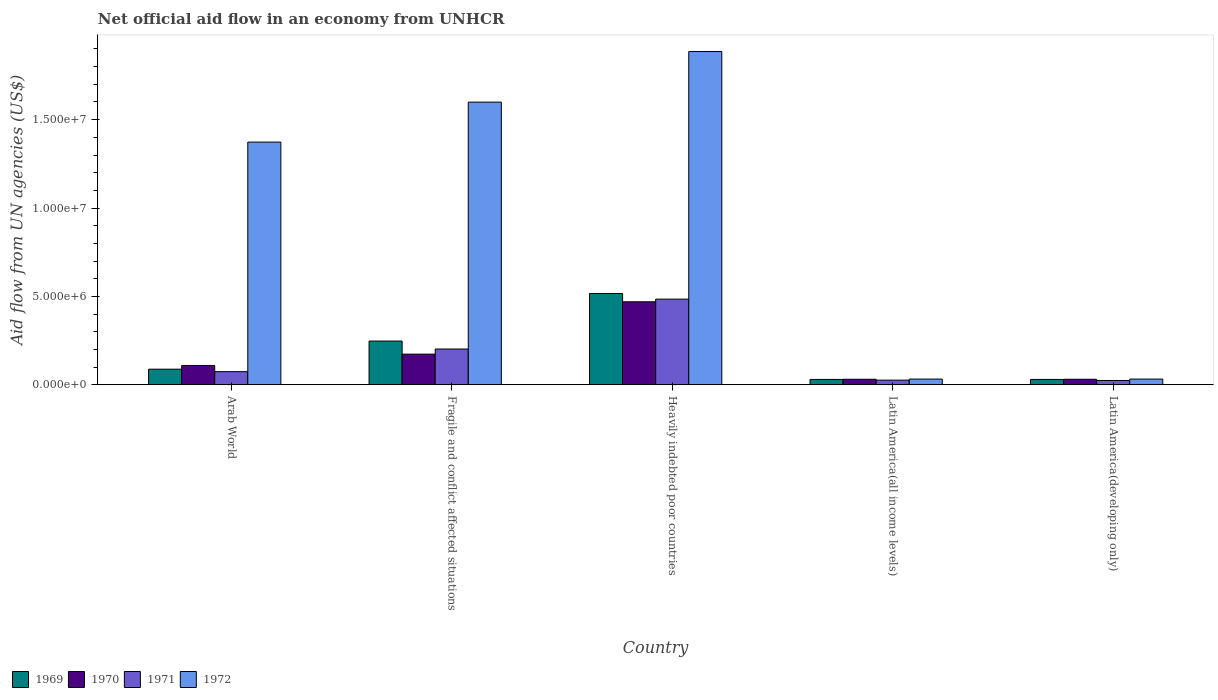How many different coloured bars are there?
Provide a short and direct response. 4. Are the number of bars per tick equal to the number of legend labels?
Provide a short and direct response. Yes. How many bars are there on the 3rd tick from the left?
Provide a short and direct response. 4. How many bars are there on the 2nd tick from the right?
Provide a short and direct response. 4. What is the label of the 2nd group of bars from the left?
Give a very brief answer. Fragile and conflict affected situations. What is the net official aid flow in 1970 in Heavily indebted poor countries?
Provide a succinct answer. 4.70e+06. Across all countries, what is the maximum net official aid flow in 1972?
Offer a terse response. 1.88e+07. In which country was the net official aid flow in 1970 maximum?
Offer a very short reply. Heavily indebted poor countries. In which country was the net official aid flow in 1970 minimum?
Your answer should be compact. Latin America(all income levels). What is the total net official aid flow in 1969 in the graph?
Your answer should be compact. 9.16e+06. What is the difference between the net official aid flow in 1969 in Arab World and that in Fragile and conflict affected situations?
Your answer should be compact. -1.59e+06. What is the difference between the net official aid flow in 1970 in Latin America(all income levels) and the net official aid flow in 1971 in Fragile and conflict affected situations?
Your answer should be very brief. -1.71e+06. What is the average net official aid flow in 1972 per country?
Keep it short and to the point. 9.85e+06. What is the ratio of the net official aid flow in 1971 in Arab World to that in Fragile and conflict affected situations?
Ensure brevity in your answer.  0.37. What is the difference between the highest and the second highest net official aid flow in 1972?
Your answer should be compact. 2.86e+06. What is the difference between the highest and the lowest net official aid flow in 1972?
Ensure brevity in your answer.  1.85e+07. In how many countries, is the net official aid flow in 1969 greater than the average net official aid flow in 1969 taken over all countries?
Your answer should be very brief. 2. Is it the case that in every country, the sum of the net official aid flow in 1971 and net official aid flow in 1969 is greater than the sum of net official aid flow in 1970 and net official aid flow in 1972?
Offer a very short reply. No. What does the 4th bar from the left in Arab World represents?
Your response must be concise. 1972. What does the 2nd bar from the right in Fragile and conflict affected situations represents?
Your response must be concise. 1971. Is it the case that in every country, the sum of the net official aid flow in 1971 and net official aid flow in 1970 is greater than the net official aid flow in 1972?
Offer a very short reply. No. Are all the bars in the graph horizontal?
Provide a succinct answer. No. Are the values on the major ticks of Y-axis written in scientific E-notation?
Provide a short and direct response. Yes. Where does the legend appear in the graph?
Your response must be concise. Bottom left. How many legend labels are there?
Your response must be concise. 4. How are the legend labels stacked?
Your answer should be very brief. Horizontal. What is the title of the graph?
Ensure brevity in your answer.  Net official aid flow in an economy from UNHCR. What is the label or title of the Y-axis?
Provide a short and direct response. Aid flow from UN agencies (US$). What is the Aid flow from UN agencies (US$) in 1969 in Arab World?
Offer a very short reply. 8.90e+05. What is the Aid flow from UN agencies (US$) in 1970 in Arab World?
Make the answer very short. 1.10e+06. What is the Aid flow from UN agencies (US$) in 1971 in Arab World?
Offer a terse response. 7.50e+05. What is the Aid flow from UN agencies (US$) of 1972 in Arab World?
Provide a succinct answer. 1.37e+07. What is the Aid flow from UN agencies (US$) in 1969 in Fragile and conflict affected situations?
Make the answer very short. 2.48e+06. What is the Aid flow from UN agencies (US$) in 1970 in Fragile and conflict affected situations?
Offer a terse response. 1.74e+06. What is the Aid flow from UN agencies (US$) of 1971 in Fragile and conflict affected situations?
Offer a terse response. 2.03e+06. What is the Aid flow from UN agencies (US$) in 1972 in Fragile and conflict affected situations?
Offer a very short reply. 1.60e+07. What is the Aid flow from UN agencies (US$) in 1969 in Heavily indebted poor countries?
Provide a succinct answer. 5.17e+06. What is the Aid flow from UN agencies (US$) in 1970 in Heavily indebted poor countries?
Your answer should be very brief. 4.70e+06. What is the Aid flow from UN agencies (US$) of 1971 in Heavily indebted poor countries?
Provide a succinct answer. 4.85e+06. What is the Aid flow from UN agencies (US$) in 1972 in Heavily indebted poor countries?
Your answer should be very brief. 1.88e+07. What is the Aid flow from UN agencies (US$) of 1970 in Latin America(all income levels)?
Your answer should be compact. 3.20e+05. What is the Aid flow from UN agencies (US$) of 1969 in Latin America(developing only)?
Provide a short and direct response. 3.10e+05. What is the Aid flow from UN agencies (US$) of 1971 in Latin America(developing only)?
Your answer should be very brief. 2.50e+05. What is the Aid flow from UN agencies (US$) in 1972 in Latin America(developing only)?
Offer a terse response. 3.30e+05. Across all countries, what is the maximum Aid flow from UN agencies (US$) in 1969?
Your answer should be very brief. 5.17e+06. Across all countries, what is the maximum Aid flow from UN agencies (US$) in 1970?
Provide a short and direct response. 4.70e+06. Across all countries, what is the maximum Aid flow from UN agencies (US$) in 1971?
Ensure brevity in your answer.  4.85e+06. Across all countries, what is the maximum Aid flow from UN agencies (US$) in 1972?
Keep it short and to the point. 1.88e+07. Across all countries, what is the minimum Aid flow from UN agencies (US$) of 1969?
Offer a very short reply. 3.10e+05. Across all countries, what is the minimum Aid flow from UN agencies (US$) in 1972?
Your answer should be very brief. 3.30e+05. What is the total Aid flow from UN agencies (US$) in 1969 in the graph?
Give a very brief answer. 9.16e+06. What is the total Aid flow from UN agencies (US$) of 1970 in the graph?
Offer a very short reply. 8.18e+06. What is the total Aid flow from UN agencies (US$) of 1971 in the graph?
Keep it short and to the point. 8.15e+06. What is the total Aid flow from UN agencies (US$) in 1972 in the graph?
Offer a terse response. 4.92e+07. What is the difference between the Aid flow from UN agencies (US$) in 1969 in Arab World and that in Fragile and conflict affected situations?
Your answer should be compact. -1.59e+06. What is the difference between the Aid flow from UN agencies (US$) in 1970 in Arab World and that in Fragile and conflict affected situations?
Offer a terse response. -6.40e+05. What is the difference between the Aid flow from UN agencies (US$) of 1971 in Arab World and that in Fragile and conflict affected situations?
Offer a terse response. -1.28e+06. What is the difference between the Aid flow from UN agencies (US$) of 1972 in Arab World and that in Fragile and conflict affected situations?
Provide a short and direct response. -2.26e+06. What is the difference between the Aid flow from UN agencies (US$) in 1969 in Arab World and that in Heavily indebted poor countries?
Provide a succinct answer. -4.28e+06. What is the difference between the Aid flow from UN agencies (US$) of 1970 in Arab World and that in Heavily indebted poor countries?
Your answer should be very brief. -3.60e+06. What is the difference between the Aid flow from UN agencies (US$) in 1971 in Arab World and that in Heavily indebted poor countries?
Make the answer very short. -4.10e+06. What is the difference between the Aid flow from UN agencies (US$) in 1972 in Arab World and that in Heavily indebted poor countries?
Make the answer very short. -5.12e+06. What is the difference between the Aid flow from UN agencies (US$) of 1969 in Arab World and that in Latin America(all income levels)?
Ensure brevity in your answer.  5.80e+05. What is the difference between the Aid flow from UN agencies (US$) of 1970 in Arab World and that in Latin America(all income levels)?
Offer a terse response. 7.80e+05. What is the difference between the Aid flow from UN agencies (US$) in 1971 in Arab World and that in Latin America(all income levels)?
Make the answer very short. 4.80e+05. What is the difference between the Aid flow from UN agencies (US$) in 1972 in Arab World and that in Latin America(all income levels)?
Your answer should be very brief. 1.34e+07. What is the difference between the Aid flow from UN agencies (US$) of 1969 in Arab World and that in Latin America(developing only)?
Provide a short and direct response. 5.80e+05. What is the difference between the Aid flow from UN agencies (US$) of 1970 in Arab World and that in Latin America(developing only)?
Offer a very short reply. 7.80e+05. What is the difference between the Aid flow from UN agencies (US$) of 1971 in Arab World and that in Latin America(developing only)?
Provide a short and direct response. 5.00e+05. What is the difference between the Aid flow from UN agencies (US$) of 1972 in Arab World and that in Latin America(developing only)?
Give a very brief answer. 1.34e+07. What is the difference between the Aid flow from UN agencies (US$) in 1969 in Fragile and conflict affected situations and that in Heavily indebted poor countries?
Provide a short and direct response. -2.69e+06. What is the difference between the Aid flow from UN agencies (US$) in 1970 in Fragile and conflict affected situations and that in Heavily indebted poor countries?
Offer a terse response. -2.96e+06. What is the difference between the Aid flow from UN agencies (US$) in 1971 in Fragile and conflict affected situations and that in Heavily indebted poor countries?
Your answer should be compact. -2.82e+06. What is the difference between the Aid flow from UN agencies (US$) of 1972 in Fragile and conflict affected situations and that in Heavily indebted poor countries?
Offer a terse response. -2.86e+06. What is the difference between the Aid flow from UN agencies (US$) in 1969 in Fragile and conflict affected situations and that in Latin America(all income levels)?
Keep it short and to the point. 2.17e+06. What is the difference between the Aid flow from UN agencies (US$) in 1970 in Fragile and conflict affected situations and that in Latin America(all income levels)?
Provide a succinct answer. 1.42e+06. What is the difference between the Aid flow from UN agencies (US$) in 1971 in Fragile and conflict affected situations and that in Latin America(all income levels)?
Your answer should be compact. 1.76e+06. What is the difference between the Aid flow from UN agencies (US$) in 1972 in Fragile and conflict affected situations and that in Latin America(all income levels)?
Your response must be concise. 1.57e+07. What is the difference between the Aid flow from UN agencies (US$) of 1969 in Fragile and conflict affected situations and that in Latin America(developing only)?
Ensure brevity in your answer.  2.17e+06. What is the difference between the Aid flow from UN agencies (US$) of 1970 in Fragile and conflict affected situations and that in Latin America(developing only)?
Provide a succinct answer. 1.42e+06. What is the difference between the Aid flow from UN agencies (US$) of 1971 in Fragile and conflict affected situations and that in Latin America(developing only)?
Provide a short and direct response. 1.78e+06. What is the difference between the Aid flow from UN agencies (US$) in 1972 in Fragile and conflict affected situations and that in Latin America(developing only)?
Keep it short and to the point. 1.57e+07. What is the difference between the Aid flow from UN agencies (US$) of 1969 in Heavily indebted poor countries and that in Latin America(all income levels)?
Ensure brevity in your answer.  4.86e+06. What is the difference between the Aid flow from UN agencies (US$) in 1970 in Heavily indebted poor countries and that in Latin America(all income levels)?
Give a very brief answer. 4.38e+06. What is the difference between the Aid flow from UN agencies (US$) of 1971 in Heavily indebted poor countries and that in Latin America(all income levels)?
Give a very brief answer. 4.58e+06. What is the difference between the Aid flow from UN agencies (US$) in 1972 in Heavily indebted poor countries and that in Latin America(all income levels)?
Offer a very short reply. 1.85e+07. What is the difference between the Aid flow from UN agencies (US$) in 1969 in Heavily indebted poor countries and that in Latin America(developing only)?
Offer a very short reply. 4.86e+06. What is the difference between the Aid flow from UN agencies (US$) in 1970 in Heavily indebted poor countries and that in Latin America(developing only)?
Provide a succinct answer. 4.38e+06. What is the difference between the Aid flow from UN agencies (US$) in 1971 in Heavily indebted poor countries and that in Latin America(developing only)?
Provide a succinct answer. 4.60e+06. What is the difference between the Aid flow from UN agencies (US$) in 1972 in Heavily indebted poor countries and that in Latin America(developing only)?
Make the answer very short. 1.85e+07. What is the difference between the Aid flow from UN agencies (US$) of 1969 in Latin America(all income levels) and that in Latin America(developing only)?
Your answer should be compact. 0. What is the difference between the Aid flow from UN agencies (US$) in 1971 in Latin America(all income levels) and that in Latin America(developing only)?
Your answer should be compact. 2.00e+04. What is the difference between the Aid flow from UN agencies (US$) of 1969 in Arab World and the Aid flow from UN agencies (US$) of 1970 in Fragile and conflict affected situations?
Offer a terse response. -8.50e+05. What is the difference between the Aid flow from UN agencies (US$) of 1969 in Arab World and the Aid flow from UN agencies (US$) of 1971 in Fragile and conflict affected situations?
Keep it short and to the point. -1.14e+06. What is the difference between the Aid flow from UN agencies (US$) in 1969 in Arab World and the Aid flow from UN agencies (US$) in 1972 in Fragile and conflict affected situations?
Keep it short and to the point. -1.51e+07. What is the difference between the Aid flow from UN agencies (US$) in 1970 in Arab World and the Aid flow from UN agencies (US$) in 1971 in Fragile and conflict affected situations?
Make the answer very short. -9.30e+05. What is the difference between the Aid flow from UN agencies (US$) of 1970 in Arab World and the Aid flow from UN agencies (US$) of 1972 in Fragile and conflict affected situations?
Provide a short and direct response. -1.49e+07. What is the difference between the Aid flow from UN agencies (US$) of 1971 in Arab World and the Aid flow from UN agencies (US$) of 1972 in Fragile and conflict affected situations?
Provide a short and direct response. -1.52e+07. What is the difference between the Aid flow from UN agencies (US$) in 1969 in Arab World and the Aid flow from UN agencies (US$) in 1970 in Heavily indebted poor countries?
Offer a very short reply. -3.81e+06. What is the difference between the Aid flow from UN agencies (US$) in 1969 in Arab World and the Aid flow from UN agencies (US$) in 1971 in Heavily indebted poor countries?
Keep it short and to the point. -3.96e+06. What is the difference between the Aid flow from UN agencies (US$) of 1969 in Arab World and the Aid flow from UN agencies (US$) of 1972 in Heavily indebted poor countries?
Make the answer very short. -1.80e+07. What is the difference between the Aid flow from UN agencies (US$) of 1970 in Arab World and the Aid flow from UN agencies (US$) of 1971 in Heavily indebted poor countries?
Give a very brief answer. -3.75e+06. What is the difference between the Aid flow from UN agencies (US$) in 1970 in Arab World and the Aid flow from UN agencies (US$) in 1972 in Heavily indebted poor countries?
Provide a short and direct response. -1.78e+07. What is the difference between the Aid flow from UN agencies (US$) of 1971 in Arab World and the Aid flow from UN agencies (US$) of 1972 in Heavily indebted poor countries?
Provide a succinct answer. -1.81e+07. What is the difference between the Aid flow from UN agencies (US$) of 1969 in Arab World and the Aid flow from UN agencies (US$) of 1970 in Latin America(all income levels)?
Keep it short and to the point. 5.70e+05. What is the difference between the Aid flow from UN agencies (US$) of 1969 in Arab World and the Aid flow from UN agencies (US$) of 1971 in Latin America(all income levels)?
Provide a short and direct response. 6.20e+05. What is the difference between the Aid flow from UN agencies (US$) of 1969 in Arab World and the Aid flow from UN agencies (US$) of 1972 in Latin America(all income levels)?
Ensure brevity in your answer.  5.60e+05. What is the difference between the Aid flow from UN agencies (US$) of 1970 in Arab World and the Aid flow from UN agencies (US$) of 1971 in Latin America(all income levels)?
Offer a very short reply. 8.30e+05. What is the difference between the Aid flow from UN agencies (US$) of 1970 in Arab World and the Aid flow from UN agencies (US$) of 1972 in Latin America(all income levels)?
Give a very brief answer. 7.70e+05. What is the difference between the Aid flow from UN agencies (US$) in 1969 in Arab World and the Aid flow from UN agencies (US$) in 1970 in Latin America(developing only)?
Ensure brevity in your answer.  5.70e+05. What is the difference between the Aid flow from UN agencies (US$) in 1969 in Arab World and the Aid flow from UN agencies (US$) in 1971 in Latin America(developing only)?
Your answer should be very brief. 6.40e+05. What is the difference between the Aid flow from UN agencies (US$) of 1969 in Arab World and the Aid flow from UN agencies (US$) of 1972 in Latin America(developing only)?
Offer a terse response. 5.60e+05. What is the difference between the Aid flow from UN agencies (US$) in 1970 in Arab World and the Aid flow from UN agencies (US$) in 1971 in Latin America(developing only)?
Offer a terse response. 8.50e+05. What is the difference between the Aid flow from UN agencies (US$) of 1970 in Arab World and the Aid flow from UN agencies (US$) of 1972 in Latin America(developing only)?
Provide a succinct answer. 7.70e+05. What is the difference between the Aid flow from UN agencies (US$) of 1969 in Fragile and conflict affected situations and the Aid flow from UN agencies (US$) of 1970 in Heavily indebted poor countries?
Keep it short and to the point. -2.22e+06. What is the difference between the Aid flow from UN agencies (US$) of 1969 in Fragile and conflict affected situations and the Aid flow from UN agencies (US$) of 1971 in Heavily indebted poor countries?
Make the answer very short. -2.37e+06. What is the difference between the Aid flow from UN agencies (US$) of 1969 in Fragile and conflict affected situations and the Aid flow from UN agencies (US$) of 1972 in Heavily indebted poor countries?
Your answer should be compact. -1.64e+07. What is the difference between the Aid flow from UN agencies (US$) of 1970 in Fragile and conflict affected situations and the Aid flow from UN agencies (US$) of 1971 in Heavily indebted poor countries?
Offer a very short reply. -3.11e+06. What is the difference between the Aid flow from UN agencies (US$) of 1970 in Fragile and conflict affected situations and the Aid flow from UN agencies (US$) of 1972 in Heavily indebted poor countries?
Offer a very short reply. -1.71e+07. What is the difference between the Aid flow from UN agencies (US$) of 1971 in Fragile and conflict affected situations and the Aid flow from UN agencies (US$) of 1972 in Heavily indebted poor countries?
Offer a very short reply. -1.68e+07. What is the difference between the Aid flow from UN agencies (US$) in 1969 in Fragile and conflict affected situations and the Aid flow from UN agencies (US$) in 1970 in Latin America(all income levels)?
Your answer should be very brief. 2.16e+06. What is the difference between the Aid flow from UN agencies (US$) in 1969 in Fragile and conflict affected situations and the Aid flow from UN agencies (US$) in 1971 in Latin America(all income levels)?
Your answer should be compact. 2.21e+06. What is the difference between the Aid flow from UN agencies (US$) in 1969 in Fragile and conflict affected situations and the Aid flow from UN agencies (US$) in 1972 in Latin America(all income levels)?
Make the answer very short. 2.15e+06. What is the difference between the Aid flow from UN agencies (US$) of 1970 in Fragile and conflict affected situations and the Aid flow from UN agencies (US$) of 1971 in Latin America(all income levels)?
Offer a terse response. 1.47e+06. What is the difference between the Aid flow from UN agencies (US$) in 1970 in Fragile and conflict affected situations and the Aid flow from UN agencies (US$) in 1972 in Latin America(all income levels)?
Provide a short and direct response. 1.41e+06. What is the difference between the Aid flow from UN agencies (US$) of 1971 in Fragile and conflict affected situations and the Aid flow from UN agencies (US$) of 1972 in Latin America(all income levels)?
Make the answer very short. 1.70e+06. What is the difference between the Aid flow from UN agencies (US$) of 1969 in Fragile and conflict affected situations and the Aid flow from UN agencies (US$) of 1970 in Latin America(developing only)?
Offer a terse response. 2.16e+06. What is the difference between the Aid flow from UN agencies (US$) of 1969 in Fragile and conflict affected situations and the Aid flow from UN agencies (US$) of 1971 in Latin America(developing only)?
Provide a succinct answer. 2.23e+06. What is the difference between the Aid flow from UN agencies (US$) of 1969 in Fragile and conflict affected situations and the Aid flow from UN agencies (US$) of 1972 in Latin America(developing only)?
Make the answer very short. 2.15e+06. What is the difference between the Aid flow from UN agencies (US$) in 1970 in Fragile and conflict affected situations and the Aid flow from UN agencies (US$) in 1971 in Latin America(developing only)?
Make the answer very short. 1.49e+06. What is the difference between the Aid flow from UN agencies (US$) of 1970 in Fragile and conflict affected situations and the Aid flow from UN agencies (US$) of 1972 in Latin America(developing only)?
Ensure brevity in your answer.  1.41e+06. What is the difference between the Aid flow from UN agencies (US$) in 1971 in Fragile and conflict affected situations and the Aid flow from UN agencies (US$) in 1972 in Latin America(developing only)?
Your response must be concise. 1.70e+06. What is the difference between the Aid flow from UN agencies (US$) of 1969 in Heavily indebted poor countries and the Aid flow from UN agencies (US$) of 1970 in Latin America(all income levels)?
Provide a succinct answer. 4.85e+06. What is the difference between the Aid flow from UN agencies (US$) in 1969 in Heavily indebted poor countries and the Aid flow from UN agencies (US$) in 1971 in Latin America(all income levels)?
Your response must be concise. 4.90e+06. What is the difference between the Aid flow from UN agencies (US$) in 1969 in Heavily indebted poor countries and the Aid flow from UN agencies (US$) in 1972 in Latin America(all income levels)?
Ensure brevity in your answer.  4.84e+06. What is the difference between the Aid flow from UN agencies (US$) of 1970 in Heavily indebted poor countries and the Aid flow from UN agencies (US$) of 1971 in Latin America(all income levels)?
Offer a very short reply. 4.43e+06. What is the difference between the Aid flow from UN agencies (US$) of 1970 in Heavily indebted poor countries and the Aid flow from UN agencies (US$) of 1972 in Latin America(all income levels)?
Keep it short and to the point. 4.37e+06. What is the difference between the Aid flow from UN agencies (US$) in 1971 in Heavily indebted poor countries and the Aid flow from UN agencies (US$) in 1972 in Latin America(all income levels)?
Ensure brevity in your answer.  4.52e+06. What is the difference between the Aid flow from UN agencies (US$) in 1969 in Heavily indebted poor countries and the Aid flow from UN agencies (US$) in 1970 in Latin America(developing only)?
Ensure brevity in your answer.  4.85e+06. What is the difference between the Aid flow from UN agencies (US$) of 1969 in Heavily indebted poor countries and the Aid flow from UN agencies (US$) of 1971 in Latin America(developing only)?
Offer a terse response. 4.92e+06. What is the difference between the Aid flow from UN agencies (US$) in 1969 in Heavily indebted poor countries and the Aid flow from UN agencies (US$) in 1972 in Latin America(developing only)?
Give a very brief answer. 4.84e+06. What is the difference between the Aid flow from UN agencies (US$) in 1970 in Heavily indebted poor countries and the Aid flow from UN agencies (US$) in 1971 in Latin America(developing only)?
Offer a very short reply. 4.45e+06. What is the difference between the Aid flow from UN agencies (US$) of 1970 in Heavily indebted poor countries and the Aid flow from UN agencies (US$) of 1972 in Latin America(developing only)?
Keep it short and to the point. 4.37e+06. What is the difference between the Aid flow from UN agencies (US$) in 1971 in Heavily indebted poor countries and the Aid flow from UN agencies (US$) in 1972 in Latin America(developing only)?
Offer a terse response. 4.52e+06. What is the difference between the Aid flow from UN agencies (US$) of 1969 in Latin America(all income levels) and the Aid flow from UN agencies (US$) of 1970 in Latin America(developing only)?
Offer a very short reply. -10000. What is the difference between the Aid flow from UN agencies (US$) in 1969 in Latin America(all income levels) and the Aid flow from UN agencies (US$) in 1971 in Latin America(developing only)?
Ensure brevity in your answer.  6.00e+04. What is the difference between the Aid flow from UN agencies (US$) of 1969 in Latin America(all income levels) and the Aid flow from UN agencies (US$) of 1972 in Latin America(developing only)?
Offer a terse response. -2.00e+04. What is the difference between the Aid flow from UN agencies (US$) of 1970 in Latin America(all income levels) and the Aid flow from UN agencies (US$) of 1971 in Latin America(developing only)?
Your answer should be compact. 7.00e+04. What is the difference between the Aid flow from UN agencies (US$) of 1970 in Latin America(all income levels) and the Aid flow from UN agencies (US$) of 1972 in Latin America(developing only)?
Make the answer very short. -10000. What is the difference between the Aid flow from UN agencies (US$) of 1971 in Latin America(all income levels) and the Aid flow from UN agencies (US$) of 1972 in Latin America(developing only)?
Give a very brief answer. -6.00e+04. What is the average Aid flow from UN agencies (US$) in 1969 per country?
Provide a succinct answer. 1.83e+06. What is the average Aid flow from UN agencies (US$) of 1970 per country?
Your response must be concise. 1.64e+06. What is the average Aid flow from UN agencies (US$) of 1971 per country?
Your response must be concise. 1.63e+06. What is the average Aid flow from UN agencies (US$) in 1972 per country?
Provide a short and direct response. 9.85e+06. What is the difference between the Aid flow from UN agencies (US$) in 1969 and Aid flow from UN agencies (US$) in 1972 in Arab World?
Your answer should be very brief. -1.28e+07. What is the difference between the Aid flow from UN agencies (US$) of 1970 and Aid flow from UN agencies (US$) of 1972 in Arab World?
Offer a terse response. -1.26e+07. What is the difference between the Aid flow from UN agencies (US$) in 1971 and Aid flow from UN agencies (US$) in 1972 in Arab World?
Provide a short and direct response. -1.30e+07. What is the difference between the Aid flow from UN agencies (US$) of 1969 and Aid flow from UN agencies (US$) of 1970 in Fragile and conflict affected situations?
Make the answer very short. 7.40e+05. What is the difference between the Aid flow from UN agencies (US$) in 1969 and Aid flow from UN agencies (US$) in 1971 in Fragile and conflict affected situations?
Keep it short and to the point. 4.50e+05. What is the difference between the Aid flow from UN agencies (US$) in 1969 and Aid flow from UN agencies (US$) in 1972 in Fragile and conflict affected situations?
Ensure brevity in your answer.  -1.35e+07. What is the difference between the Aid flow from UN agencies (US$) in 1970 and Aid flow from UN agencies (US$) in 1971 in Fragile and conflict affected situations?
Provide a short and direct response. -2.90e+05. What is the difference between the Aid flow from UN agencies (US$) in 1970 and Aid flow from UN agencies (US$) in 1972 in Fragile and conflict affected situations?
Give a very brief answer. -1.42e+07. What is the difference between the Aid flow from UN agencies (US$) of 1971 and Aid flow from UN agencies (US$) of 1972 in Fragile and conflict affected situations?
Keep it short and to the point. -1.40e+07. What is the difference between the Aid flow from UN agencies (US$) of 1969 and Aid flow from UN agencies (US$) of 1970 in Heavily indebted poor countries?
Make the answer very short. 4.70e+05. What is the difference between the Aid flow from UN agencies (US$) of 1969 and Aid flow from UN agencies (US$) of 1971 in Heavily indebted poor countries?
Keep it short and to the point. 3.20e+05. What is the difference between the Aid flow from UN agencies (US$) in 1969 and Aid flow from UN agencies (US$) in 1972 in Heavily indebted poor countries?
Your answer should be very brief. -1.37e+07. What is the difference between the Aid flow from UN agencies (US$) in 1970 and Aid flow from UN agencies (US$) in 1971 in Heavily indebted poor countries?
Offer a very short reply. -1.50e+05. What is the difference between the Aid flow from UN agencies (US$) of 1970 and Aid flow from UN agencies (US$) of 1972 in Heavily indebted poor countries?
Make the answer very short. -1.42e+07. What is the difference between the Aid flow from UN agencies (US$) of 1971 and Aid flow from UN agencies (US$) of 1972 in Heavily indebted poor countries?
Your answer should be compact. -1.40e+07. What is the difference between the Aid flow from UN agencies (US$) in 1969 and Aid flow from UN agencies (US$) in 1971 in Latin America(all income levels)?
Keep it short and to the point. 4.00e+04. What is the difference between the Aid flow from UN agencies (US$) of 1969 and Aid flow from UN agencies (US$) of 1972 in Latin America(all income levels)?
Offer a very short reply. -2.00e+04. What is the difference between the Aid flow from UN agencies (US$) of 1970 and Aid flow from UN agencies (US$) of 1971 in Latin America(all income levels)?
Give a very brief answer. 5.00e+04. What is the difference between the Aid flow from UN agencies (US$) in 1969 and Aid flow from UN agencies (US$) in 1970 in Latin America(developing only)?
Give a very brief answer. -10000. What is the difference between the Aid flow from UN agencies (US$) in 1971 and Aid flow from UN agencies (US$) in 1972 in Latin America(developing only)?
Provide a succinct answer. -8.00e+04. What is the ratio of the Aid flow from UN agencies (US$) in 1969 in Arab World to that in Fragile and conflict affected situations?
Your answer should be very brief. 0.36. What is the ratio of the Aid flow from UN agencies (US$) in 1970 in Arab World to that in Fragile and conflict affected situations?
Ensure brevity in your answer.  0.63. What is the ratio of the Aid flow from UN agencies (US$) of 1971 in Arab World to that in Fragile and conflict affected situations?
Ensure brevity in your answer.  0.37. What is the ratio of the Aid flow from UN agencies (US$) of 1972 in Arab World to that in Fragile and conflict affected situations?
Give a very brief answer. 0.86. What is the ratio of the Aid flow from UN agencies (US$) of 1969 in Arab World to that in Heavily indebted poor countries?
Offer a very short reply. 0.17. What is the ratio of the Aid flow from UN agencies (US$) in 1970 in Arab World to that in Heavily indebted poor countries?
Keep it short and to the point. 0.23. What is the ratio of the Aid flow from UN agencies (US$) in 1971 in Arab World to that in Heavily indebted poor countries?
Your response must be concise. 0.15. What is the ratio of the Aid flow from UN agencies (US$) in 1972 in Arab World to that in Heavily indebted poor countries?
Make the answer very short. 0.73. What is the ratio of the Aid flow from UN agencies (US$) of 1969 in Arab World to that in Latin America(all income levels)?
Offer a terse response. 2.87. What is the ratio of the Aid flow from UN agencies (US$) in 1970 in Arab World to that in Latin America(all income levels)?
Your answer should be very brief. 3.44. What is the ratio of the Aid flow from UN agencies (US$) of 1971 in Arab World to that in Latin America(all income levels)?
Make the answer very short. 2.78. What is the ratio of the Aid flow from UN agencies (US$) of 1972 in Arab World to that in Latin America(all income levels)?
Give a very brief answer. 41.61. What is the ratio of the Aid flow from UN agencies (US$) in 1969 in Arab World to that in Latin America(developing only)?
Your answer should be compact. 2.87. What is the ratio of the Aid flow from UN agencies (US$) in 1970 in Arab World to that in Latin America(developing only)?
Make the answer very short. 3.44. What is the ratio of the Aid flow from UN agencies (US$) of 1972 in Arab World to that in Latin America(developing only)?
Provide a succinct answer. 41.61. What is the ratio of the Aid flow from UN agencies (US$) of 1969 in Fragile and conflict affected situations to that in Heavily indebted poor countries?
Make the answer very short. 0.48. What is the ratio of the Aid flow from UN agencies (US$) of 1970 in Fragile and conflict affected situations to that in Heavily indebted poor countries?
Give a very brief answer. 0.37. What is the ratio of the Aid flow from UN agencies (US$) of 1971 in Fragile and conflict affected situations to that in Heavily indebted poor countries?
Ensure brevity in your answer.  0.42. What is the ratio of the Aid flow from UN agencies (US$) of 1972 in Fragile and conflict affected situations to that in Heavily indebted poor countries?
Ensure brevity in your answer.  0.85. What is the ratio of the Aid flow from UN agencies (US$) in 1970 in Fragile and conflict affected situations to that in Latin America(all income levels)?
Your response must be concise. 5.44. What is the ratio of the Aid flow from UN agencies (US$) in 1971 in Fragile and conflict affected situations to that in Latin America(all income levels)?
Keep it short and to the point. 7.52. What is the ratio of the Aid flow from UN agencies (US$) of 1972 in Fragile and conflict affected situations to that in Latin America(all income levels)?
Provide a short and direct response. 48.45. What is the ratio of the Aid flow from UN agencies (US$) of 1970 in Fragile and conflict affected situations to that in Latin America(developing only)?
Provide a short and direct response. 5.44. What is the ratio of the Aid flow from UN agencies (US$) of 1971 in Fragile and conflict affected situations to that in Latin America(developing only)?
Make the answer very short. 8.12. What is the ratio of the Aid flow from UN agencies (US$) of 1972 in Fragile and conflict affected situations to that in Latin America(developing only)?
Ensure brevity in your answer.  48.45. What is the ratio of the Aid flow from UN agencies (US$) of 1969 in Heavily indebted poor countries to that in Latin America(all income levels)?
Keep it short and to the point. 16.68. What is the ratio of the Aid flow from UN agencies (US$) in 1970 in Heavily indebted poor countries to that in Latin America(all income levels)?
Make the answer very short. 14.69. What is the ratio of the Aid flow from UN agencies (US$) of 1971 in Heavily indebted poor countries to that in Latin America(all income levels)?
Your answer should be compact. 17.96. What is the ratio of the Aid flow from UN agencies (US$) in 1972 in Heavily indebted poor countries to that in Latin America(all income levels)?
Provide a succinct answer. 57.12. What is the ratio of the Aid flow from UN agencies (US$) of 1969 in Heavily indebted poor countries to that in Latin America(developing only)?
Your response must be concise. 16.68. What is the ratio of the Aid flow from UN agencies (US$) of 1970 in Heavily indebted poor countries to that in Latin America(developing only)?
Offer a very short reply. 14.69. What is the ratio of the Aid flow from UN agencies (US$) of 1972 in Heavily indebted poor countries to that in Latin America(developing only)?
Your response must be concise. 57.12. What is the ratio of the Aid flow from UN agencies (US$) in 1970 in Latin America(all income levels) to that in Latin America(developing only)?
Give a very brief answer. 1. What is the ratio of the Aid flow from UN agencies (US$) of 1971 in Latin America(all income levels) to that in Latin America(developing only)?
Ensure brevity in your answer.  1.08. What is the ratio of the Aid flow from UN agencies (US$) in 1972 in Latin America(all income levels) to that in Latin America(developing only)?
Provide a short and direct response. 1. What is the difference between the highest and the second highest Aid flow from UN agencies (US$) of 1969?
Your answer should be very brief. 2.69e+06. What is the difference between the highest and the second highest Aid flow from UN agencies (US$) in 1970?
Keep it short and to the point. 2.96e+06. What is the difference between the highest and the second highest Aid flow from UN agencies (US$) in 1971?
Make the answer very short. 2.82e+06. What is the difference between the highest and the second highest Aid flow from UN agencies (US$) of 1972?
Your answer should be compact. 2.86e+06. What is the difference between the highest and the lowest Aid flow from UN agencies (US$) of 1969?
Keep it short and to the point. 4.86e+06. What is the difference between the highest and the lowest Aid flow from UN agencies (US$) in 1970?
Keep it short and to the point. 4.38e+06. What is the difference between the highest and the lowest Aid flow from UN agencies (US$) in 1971?
Ensure brevity in your answer.  4.60e+06. What is the difference between the highest and the lowest Aid flow from UN agencies (US$) of 1972?
Your answer should be compact. 1.85e+07. 